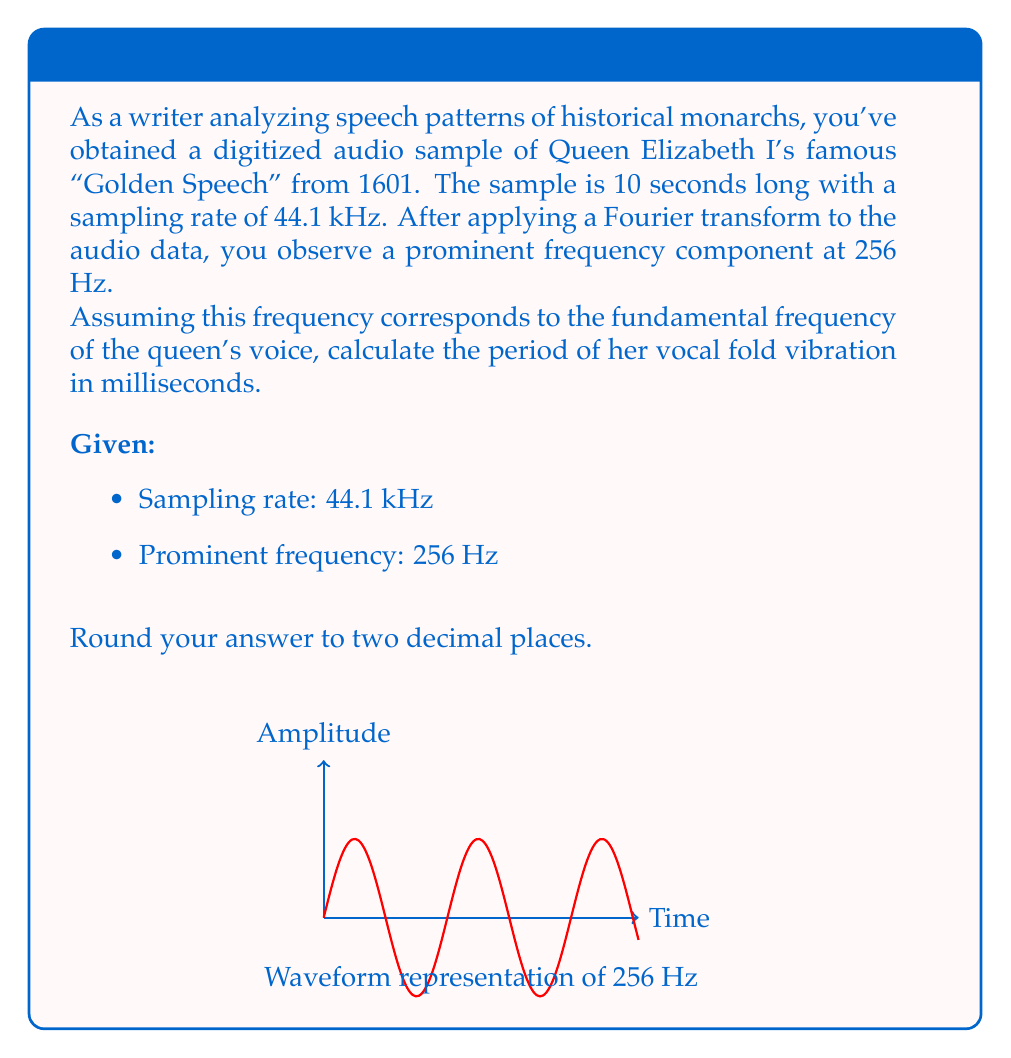Could you help me with this problem? Let's approach this step-by-step:

1) The Fourier transform has revealed a prominent frequency of 256 Hz in Queen Elizabeth I's speech. This frequency represents the number of cycles per second of her vocal fold vibration.

2) To find the period of vibration, we need to calculate the reciprocal of the frequency. The period (T) is related to frequency (f) by the equation:

   $$T = \frac{1}{f}$$

3) Substituting the given frequency:

   $$T = \frac{1}{256 \text{ Hz}}$$

4) Simplify:
   
   $$T = 0.00390625 \text{ seconds}$$

5) Convert to milliseconds by multiplying by 1000:

   $$T = 0.00390625 \times 1000 = 3.90625 \text{ ms}$$

6) Rounding to two decimal places:

   $$T \approx 3.91 \text{ ms}$$

Thus, the period of Queen Elizabeth I's vocal fold vibration, based on the Fourier analysis of her "Golden Speech," is approximately 3.91 milliseconds.
Answer: 3.91 ms 